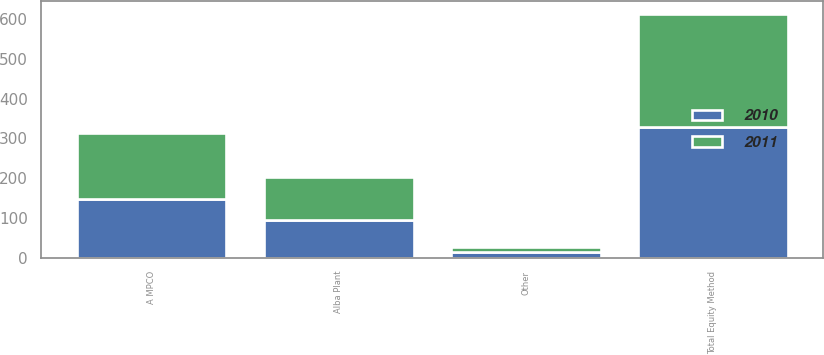<chart> <loc_0><loc_0><loc_500><loc_500><stacked_bar_chart><ecel><fcel>A MPCO<fcel>Alba Plant<fcel>Other<fcel>Total Equity Method<nl><fcel>2010<fcel>147<fcel>96<fcel>14<fcel>329<nl><fcel>2011<fcel>166<fcel>107<fcel>12<fcel>285<nl></chart> 